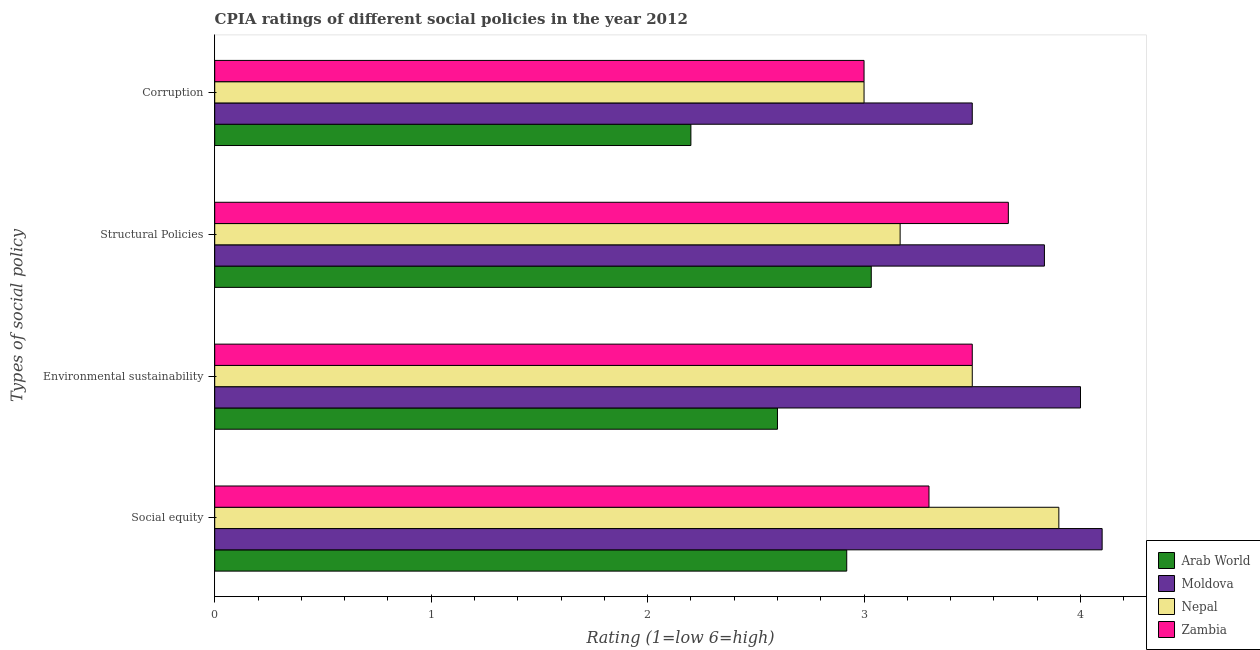How many different coloured bars are there?
Offer a terse response. 4. Are the number of bars on each tick of the Y-axis equal?
Ensure brevity in your answer.  Yes. How many bars are there on the 3rd tick from the top?
Offer a terse response. 4. What is the label of the 2nd group of bars from the top?
Your answer should be very brief. Structural Policies. Across all countries, what is the maximum cpia rating of social equity?
Keep it short and to the point. 4.1. Across all countries, what is the minimum cpia rating of environmental sustainability?
Make the answer very short. 2.6. In which country was the cpia rating of structural policies maximum?
Offer a very short reply. Moldova. In which country was the cpia rating of environmental sustainability minimum?
Provide a succinct answer. Arab World. What is the total cpia rating of social equity in the graph?
Provide a succinct answer. 14.22. What is the difference between the cpia rating of social equity in Arab World and that in Moldova?
Your answer should be very brief. -1.18. What is the average cpia rating of structural policies per country?
Your answer should be compact. 3.42. What is the difference between the cpia rating of structural policies and cpia rating of environmental sustainability in Zambia?
Offer a terse response. 0.17. In how many countries, is the cpia rating of corruption greater than 3.8 ?
Provide a short and direct response. 0. What is the ratio of the cpia rating of corruption in Nepal to that in Zambia?
Offer a very short reply. 1. What is the difference between the highest and the second highest cpia rating of structural policies?
Ensure brevity in your answer.  0.17. What is the difference between the highest and the lowest cpia rating of corruption?
Your response must be concise. 1.3. Is the sum of the cpia rating of environmental sustainability in Moldova and Zambia greater than the maximum cpia rating of corruption across all countries?
Make the answer very short. Yes. What does the 3rd bar from the top in Structural Policies represents?
Ensure brevity in your answer.  Moldova. What does the 4th bar from the bottom in Social equity represents?
Your answer should be very brief. Zambia. Is it the case that in every country, the sum of the cpia rating of social equity and cpia rating of environmental sustainability is greater than the cpia rating of structural policies?
Ensure brevity in your answer.  Yes. How many bars are there?
Keep it short and to the point. 16. What is the difference between two consecutive major ticks on the X-axis?
Offer a terse response. 1. Does the graph contain any zero values?
Provide a succinct answer. No. What is the title of the graph?
Provide a short and direct response. CPIA ratings of different social policies in the year 2012. Does "High income: nonOECD" appear as one of the legend labels in the graph?
Offer a terse response. No. What is the label or title of the X-axis?
Ensure brevity in your answer.  Rating (1=low 6=high). What is the label or title of the Y-axis?
Offer a very short reply. Types of social policy. What is the Rating (1=low 6=high) in Arab World in Social equity?
Your answer should be compact. 2.92. What is the Rating (1=low 6=high) of Moldova in Social equity?
Provide a short and direct response. 4.1. What is the Rating (1=low 6=high) in Nepal in Social equity?
Your answer should be very brief. 3.9. What is the Rating (1=low 6=high) in Zambia in Social equity?
Give a very brief answer. 3.3. What is the Rating (1=low 6=high) of Arab World in Environmental sustainability?
Give a very brief answer. 2.6. What is the Rating (1=low 6=high) in Nepal in Environmental sustainability?
Provide a succinct answer. 3.5. What is the Rating (1=low 6=high) in Zambia in Environmental sustainability?
Offer a terse response. 3.5. What is the Rating (1=low 6=high) in Arab World in Structural Policies?
Keep it short and to the point. 3.03. What is the Rating (1=low 6=high) of Moldova in Structural Policies?
Make the answer very short. 3.83. What is the Rating (1=low 6=high) in Nepal in Structural Policies?
Keep it short and to the point. 3.17. What is the Rating (1=low 6=high) in Zambia in Structural Policies?
Ensure brevity in your answer.  3.67. Across all Types of social policy, what is the maximum Rating (1=low 6=high) of Arab World?
Your response must be concise. 3.03. Across all Types of social policy, what is the maximum Rating (1=low 6=high) in Moldova?
Provide a short and direct response. 4.1. Across all Types of social policy, what is the maximum Rating (1=low 6=high) of Zambia?
Your answer should be compact. 3.67. Across all Types of social policy, what is the minimum Rating (1=low 6=high) in Moldova?
Your response must be concise. 3.5. What is the total Rating (1=low 6=high) in Arab World in the graph?
Offer a very short reply. 10.75. What is the total Rating (1=low 6=high) in Moldova in the graph?
Make the answer very short. 15.43. What is the total Rating (1=low 6=high) in Nepal in the graph?
Your answer should be very brief. 13.57. What is the total Rating (1=low 6=high) in Zambia in the graph?
Provide a short and direct response. 13.47. What is the difference between the Rating (1=low 6=high) in Arab World in Social equity and that in Environmental sustainability?
Your response must be concise. 0.32. What is the difference between the Rating (1=low 6=high) in Moldova in Social equity and that in Environmental sustainability?
Provide a short and direct response. 0.1. What is the difference between the Rating (1=low 6=high) of Nepal in Social equity and that in Environmental sustainability?
Give a very brief answer. 0.4. What is the difference between the Rating (1=low 6=high) of Arab World in Social equity and that in Structural Policies?
Ensure brevity in your answer.  -0.11. What is the difference between the Rating (1=low 6=high) of Moldova in Social equity and that in Structural Policies?
Your answer should be compact. 0.27. What is the difference between the Rating (1=low 6=high) in Nepal in Social equity and that in Structural Policies?
Provide a short and direct response. 0.73. What is the difference between the Rating (1=low 6=high) in Zambia in Social equity and that in Structural Policies?
Ensure brevity in your answer.  -0.37. What is the difference between the Rating (1=low 6=high) of Arab World in Social equity and that in Corruption?
Your answer should be compact. 0.72. What is the difference between the Rating (1=low 6=high) of Nepal in Social equity and that in Corruption?
Your answer should be very brief. 0.9. What is the difference between the Rating (1=low 6=high) of Arab World in Environmental sustainability and that in Structural Policies?
Provide a succinct answer. -0.43. What is the difference between the Rating (1=low 6=high) in Zambia in Environmental sustainability and that in Structural Policies?
Offer a very short reply. -0.17. What is the difference between the Rating (1=low 6=high) of Zambia in Environmental sustainability and that in Corruption?
Offer a terse response. 0.5. What is the difference between the Rating (1=low 6=high) of Arab World in Structural Policies and that in Corruption?
Offer a very short reply. 0.83. What is the difference between the Rating (1=low 6=high) of Nepal in Structural Policies and that in Corruption?
Give a very brief answer. 0.17. What is the difference between the Rating (1=low 6=high) in Arab World in Social equity and the Rating (1=low 6=high) in Moldova in Environmental sustainability?
Give a very brief answer. -1.08. What is the difference between the Rating (1=low 6=high) of Arab World in Social equity and the Rating (1=low 6=high) of Nepal in Environmental sustainability?
Make the answer very short. -0.58. What is the difference between the Rating (1=low 6=high) of Arab World in Social equity and the Rating (1=low 6=high) of Zambia in Environmental sustainability?
Offer a very short reply. -0.58. What is the difference between the Rating (1=low 6=high) in Moldova in Social equity and the Rating (1=low 6=high) in Nepal in Environmental sustainability?
Provide a succinct answer. 0.6. What is the difference between the Rating (1=low 6=high) of Arab World in Social equity and the Rating (1=low 6=high) of Moldova in Structural Policies?
Provide a short and direct response. -0.91. What is the difference between the Rating (1=low 6=high) in Arab World in Social equity and the Rating (1=low 6=high) in Nepal in Structural Policies?
Your answer should be very brief. -0.25. What is the difference between the Rating (1=low 6=high) in Arab World in Social equity and the Rating (1=low 6=high) in Zambia in Structural Policies?
Offer a terse response. -0.75. What is the difference between the Rating (1=low 6=high) of Moldova in Social equity and the Rating (1=low 6=high) of Zambia in Structural Policies?
Provide a short and direct response. 0.43. What is the difference between the Rating (1=low 6=high) of Nepal in Social equity and the Rating (1=low 6=high) of Zambia in Structural Policies?
Your answer should be compact. 0.23. What is the difference between the Rating (1=low 6=high) in Arab World in Social equity and the Rating (1=low 6=high) in Moldova in Corruption?
Give a very brief answer. -0.58. What is the difference between the Rating (1=low 6=high) in Arab World in Social equity and the Rating (1=low 6=high) in Nepal in Corruption?
Provide a succinct answer. -0.08. What is the difference between the Rating (1=low 6=high) in Arab World in Social equity and the Rating (1=low 6=high) in Zambia in Corruption?
Your answer should be compact. -0.08. What is the difference between the Rating (1=low 6=high) in Moldova in Social equity and the Rating (1=low 6=high) in Nepal in Corruption?
Provide a succinct answer. 1.1. What is the difference between the Rating (1=low 6=high) of Nepal in Social equity and the Rating (1=low 6=high) of Zambia in Corruption?
Provide a short and direct response. 0.9. What is the difference between the Rating (1=low 6=high) in Arab World in Environmental sustainability and the Rating (1=low 6=high) in Moldova in Structural Policies?
Your response must be concise. -1.23. What is the difference between the Rating (1=low 6=high) of Arab World in Environmental sustainability and the Rating (1=low 6=high) of Nepal in Structural Policies?
Give a very brief answer. -0.57. What is the difference between the Rating (1=low 6=high) of Arab World in Environmental sustainability and the Rating (1=low 6=high) of Zambia in Structural Policies?
Your answer should be very brief. -1.07. What is the difference between the Rating (1=low 6=high) of Moldova in Environmental sustainability and the Rating (1=low 6=high) of Nepal in Structural Policies?
Your answer should be very brief. 0.83. What is the difference between the Rating (1=low 6=high) in Moldova in Environmental sustainability and the Rating (1=low 6=high) in Zambia in Structural Policies?
Provide a short and direct response. 0.33. What is the difference between the Rating (1=low 6=high) of Arab World in Environmental sustainability and the Rating (1=low 6=high) of Zambia in Corruption?
Your response must be concise. -0.4. What is the difference between the Rating (1=low 6=high) in Moldova in Environmental sustainability and the Rating (1=low 6=high) in Nepal in Corruption?
Provide a succinct answer. 1. What is the difference between the Rating (1=low 6=high) of Nepal in Environmental sustainability and the Rating (1=low 6=high) of Zambia in Corruption?
Keep it short and to the point. 0.5. What is the difference between the Rating (1=low 6=high) of Arab World in Structural Policies and the Rating (1=low 6=high) of Moldova in Corruption?
Keep it short and to the point. -0.47. What is the difference between the Rating (1=low 6=high) of Arab World in Structural Policies and the Rating (1=low 6=high) of Nepal in Corruption?
Offer a very short reply. 0.03. What is the difference between the Rating (1=low 6=high) of Moldova in Structural Policies and the Rating (1=low 6=high) of Zambia in Corruption?
Make the answer very short. 0.83. What is the difference between the Rating (1=low 6=high) in Nepal in Structural Policies and the Rating (1=low 6=high) in Zambia in Corruption?
Offer a terse response. 0.17. What is the average Rating (1=low 6=high) of Arab World per Types of social policy?
Offer a very short reply. 2.69. What is the average Rating (1=low 6=high) of Moldova per Types of social policy?
Provide a short and direct response. 3.86. What is the average Rating (1=low 6=high) of Nepal per Types of social policy?
Provide a short and direct response. 3.39. What is the average Rating (1=low 6=high) in Zambia per Types of social policy?
Ensure brevity in your answer.  3.37. What is the difference between the Rating (1=low 6=high) of Arab World and Rating (1=low 6=high) of Moldova in Social equity?
Your answer should be very brief. -1.18. What is the difference between the Rating (1=low 6=high) in Arab World and Rating (1=low 6=high) in Nepal in Social equity?
Offer a terse response. -0.98. What is the difference between the Rating (1=low 6=high) in Arab World and Rating (1=low 6=high) in Zambia in Social equity?
Make the answer very short. -0.38. What is the difference between the Rating (1=low 6=high) in Moldova and Rating (1=low 6=high) in Nepal in Social equity?
Your answer should be compact. 0.2. What is the difference between the Rating (1=low 6=high) of Moldova and Rating (1=low 6=high) of Zambia in Social equity?
Keep it short and to the point. 0.8. What is the difference between the Rating (1=low 6=high) of Nepal and Rating (1=low 6=high) of Zambia in Social equity?
Keep it short and to the point. 0.6. What is the difference between the Rating (1=low 6=high) in Arab World and Rating (1=low 6=high) in Moldova in Structural Policies?
Your answer should be compact. -0.8. What is the difference between the Rating (1=low 6=high) of Arab World and Rating (1=low 6=high) of Nepal in Structural Policies?
Make the answer very short. -0.13. What is the difference between the Rating (1=low 6=high) of Arab World and Rating (1=low 6=high) of Zambia in Structural Policies?
Your response must be concise. -0.63. What is the difference between the Rating (1=low 6=high) of Moldova and Rating (1=low 6=high) of Zambia in Structural Policies?
Offer a very short reply. 0.17. What is the difference between the Rating (1=low 6=high) in Nepal and Rating (1=low 6=high) in Zambia in Structural Policies?
Make the answer very short. -0.5. What is the difference between the Rating (1=low 6=high) in Arab World and Rating (1=low 6=high) in Moldova in Corruption?
Make the answer very short. -1.3. What is the difference between the Rating (1=low 6=high) of Nepal and Rating (1=low 6=high) of Zambia in Corruption?
Your response must be concise. 0. What is the ratio of the Rating (1=low 6=high) in Arab World in Social equity to that in Environmental sustainability?
Provide a succinct answer. 1.12. What is the ratio of the Rating (1=low 6=high) of Nepal in Social equity to that in Environmental sustainability?
Your answer should be compact. 1.11. What is the ratio of the Rating (1=low 6=high) in Zambia in Social equity to that in Environmental sustainability?
Make the answer very short. 0.94. What is the ratio of the Rating (1=low 6=high) of Arab World in Social equity to that in Structural Policies?
Your answer should be compact. 0.96. What is the ratio of the Rating (1=low 6=high) in Moldova in Social equity to that in Structural Policies?
Provide a succinct answer. 1.07. What is the ratio of the Rating (1=low 6=high) in Nepal in Social equity to that in Structural Policies?
Offer a very short reply. 1.23. What is the ratio of the Rating (1=low 6=high) of Arab World in Social equity to that in Corruption?
Offer a very short reply. 1.33. What is the ratio of the Rating (1=low 6=high) in Moldova in Social equity to that in Corruption?
Your answer should be very brief. 1.17. What is the ratio of the Rating (1=low 6=high) of Nepal in Social equity to that in Corruption?
Offer a very short reply. 1.3. What is the ratio of the Rating (1=low 6=high) of Moldova in Environmental sustainability to that in Structural Policies?
Your answer should be very brief. 1.04. What is the ratio of the Rating (1=low 6=high) in Nepal in Environmental sustainability to that in Structural Policies?
Provide a succinct answer. 1.11. What is the ratio of the Rating (1=low 6=high) of Zambia in Environmental sustainability to that in Structural Policies?
Offer a terse response. 0.95. What is the ratio of the Rating (1=low 6=high) in Arab World in Environmental sustainability to that in Corruption?
Provide a succinct answer. 1.18. What is the ratio of the Rating (1=low 6=high) of Moldova in Environmental sustainability to that in Corruption?
Ensure brevity in your answer.  1.14. What is the ratio of the Rating (1=low 6=high) in Zambia in Environmental sustainability to that in Corruption?
Offer a terse response. 1.17. What is the ratio of the Rating (1=low 6=high) in Arab World in Structural Policies to that in Corruption?
Your response must be concise. 1.38. What is the ratio of the Rating (1=low 6=high) of Moldova in Structural Policies to that in Corruption?
Make the answer very short. 1.1. What is the ratio of the Rating (1=low 6=high) in Nepal in Structural Policies to that in Corruption?
Offer a terse response. 1.06. What is the ratio of the Rating (1=low 6=high) of Zambia in Structural Policies to that in Corruption?
Offer a terse response. 1.22. What is the difference between the highest and the second highest Rating (1=low 6=high) in Arab World?
Your answer should be compact. 0.11. What is the difference between the highest and the second highest Rating (1=low 6=high) in Nepal?
Keep it short and to the point. 0.4. What is the difference between the highest and the lowest Rating (1=low 6=high) of Nepal?
Offer a very short reply. 0.9. What is the difference between the highest and the lowest Rating (1=low 6=high) in Zambia?
Offer a terse response. 0.67. 